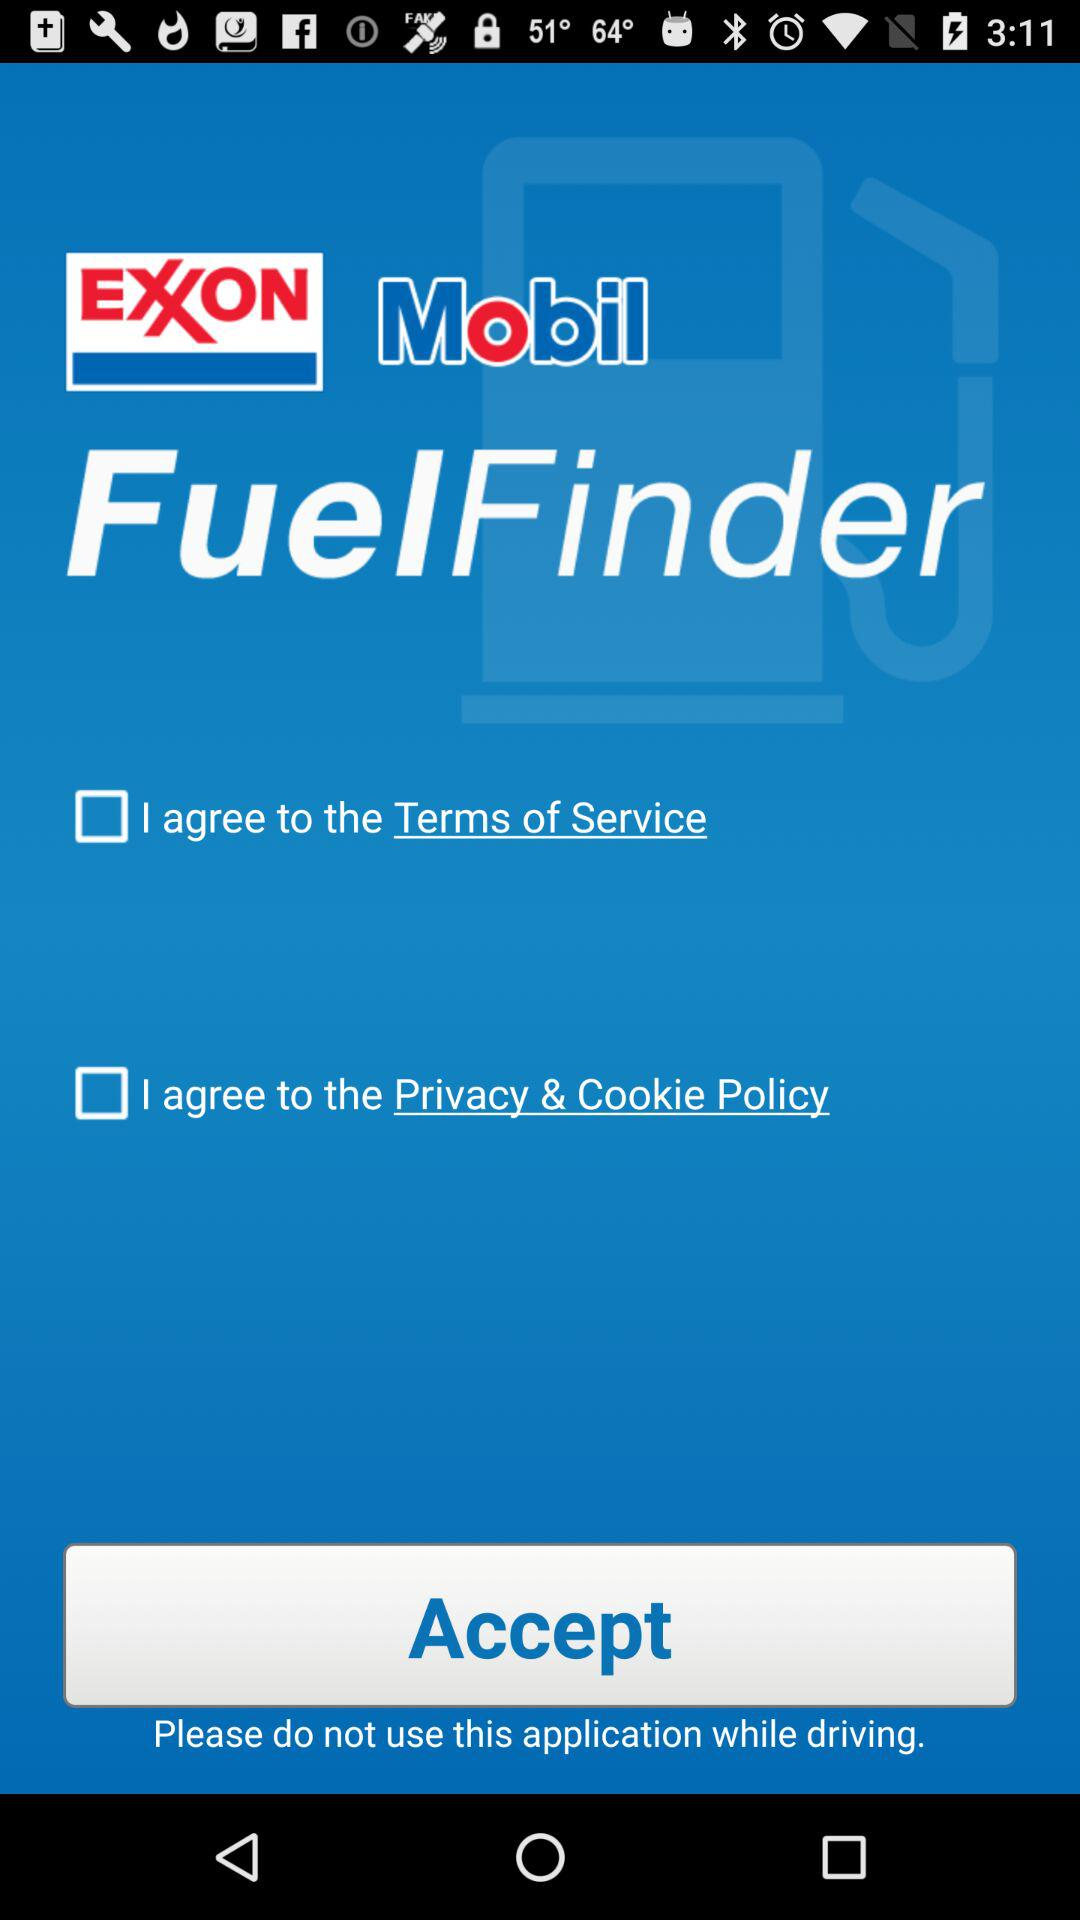What is the status of the option that includes agreement to the “Terms of Service”? The status is "off". 